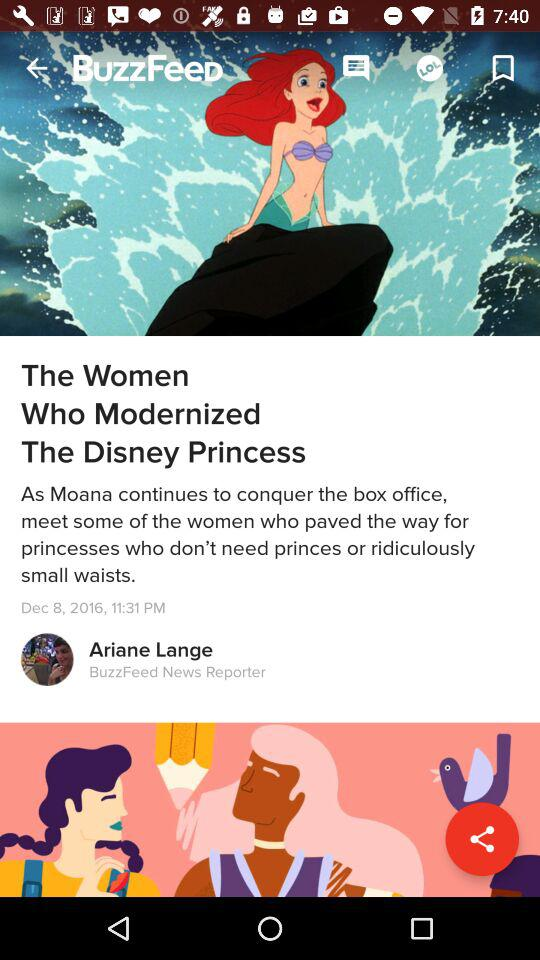What's the headline of the article? The headline of the article is "The Women Who Modernized The Disney Princess". 